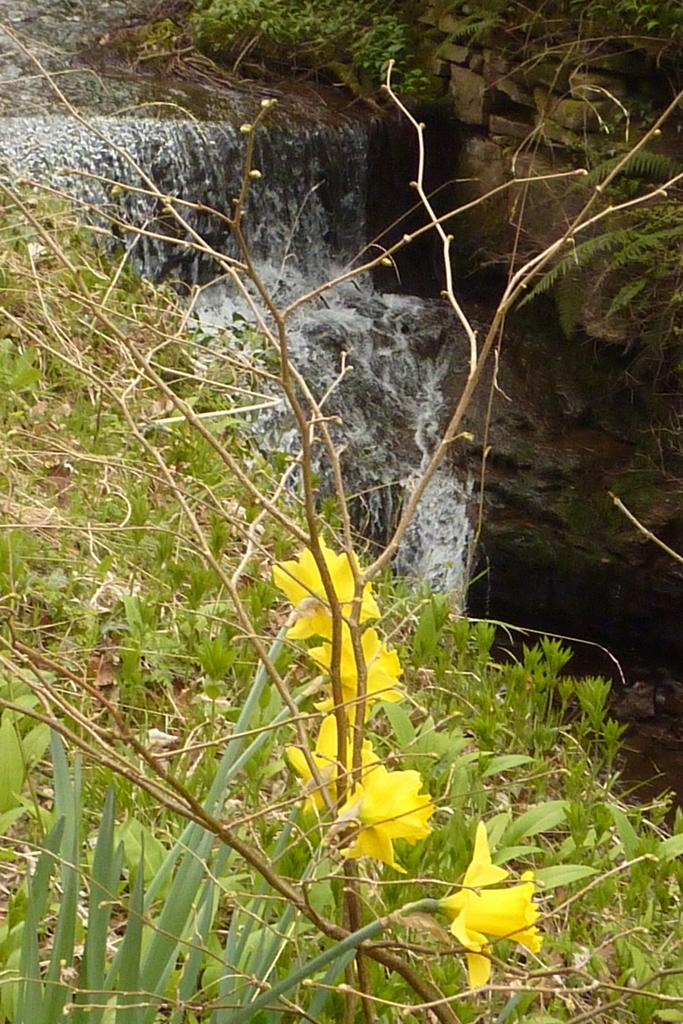What natural feature is the main subject of the image? There is a waterfall in the image. What type of flowers can be seen in the image? There are yellow color flowers on a plant in the image. What else can be seen in the background of the image? There are plants visible in the background of the image. What type of art is being created by the waterfall in the image? There is no art being created by the waterfall in the image; it is a natural feature. 